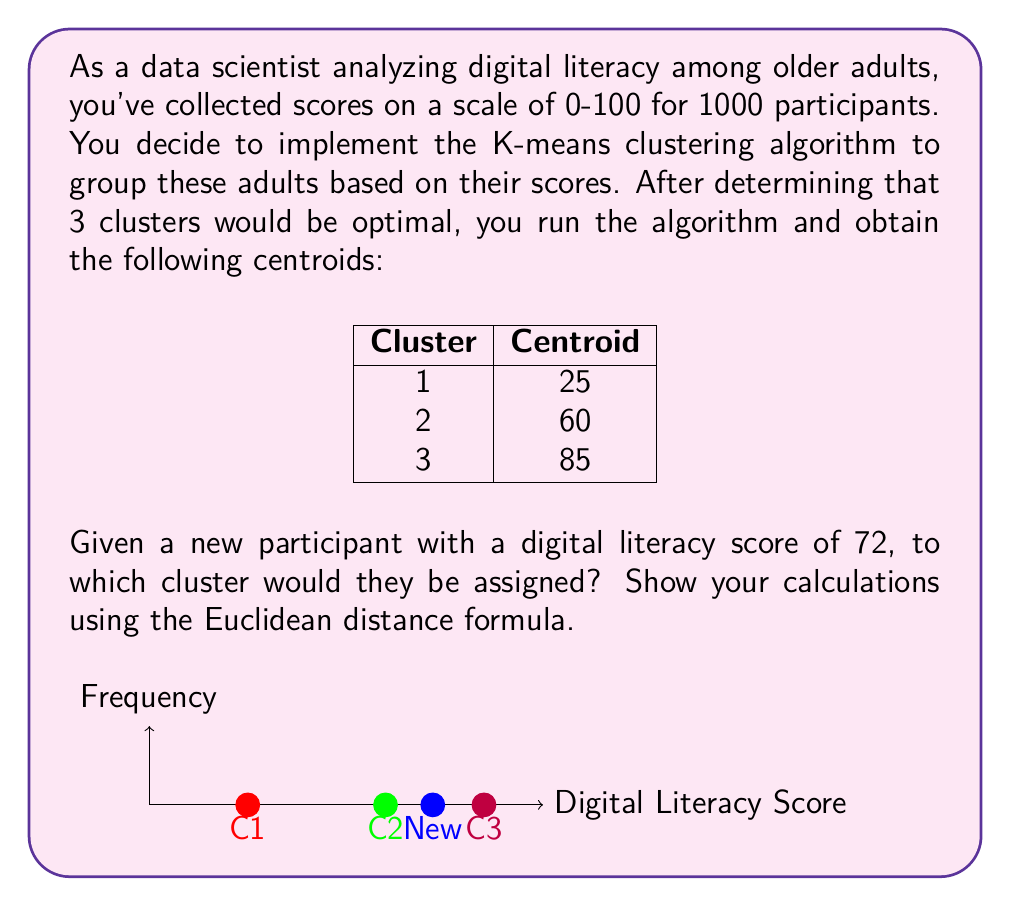Show me your answer to this math problem. To determine which cluster the new participant belongs to, we need to calculate the Euclidean distance between their score and each cluster centroid. The cluster with the smallest distance will be the one assigned to the new participant.

The Euclidean distance formula for one-dimensional data is:

$$d = \sqrt{(x_1 - x_2)^2}$$

Where $x_1$ is the new participant's score and $x_2$ is the centroid score.

Let's calculate the distance to each cluster:

1. Distance to Cluster 1:
   $$d_1 = \sqrt{(72 - 25)^2} = \sqrt{47^2} = 47$$

2. Distance to Cluster 2:
   $$d_2 = \sqrt{(72 - 60)^2} = \sqrt{12^2} = 12$$

3. Distance to Cluster 3:
   $$d_3 = \sqrt{(72 - 85)^2} = \sqrt{(-13)^2} = 13$$

The smallest distance is 12, which corresponds to Cluster 2.
Answer: Cluster 2 